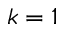Convert formula to latex. <formula><loc_0><loc_0><loc_500><loc_500>k = 1</formula> 